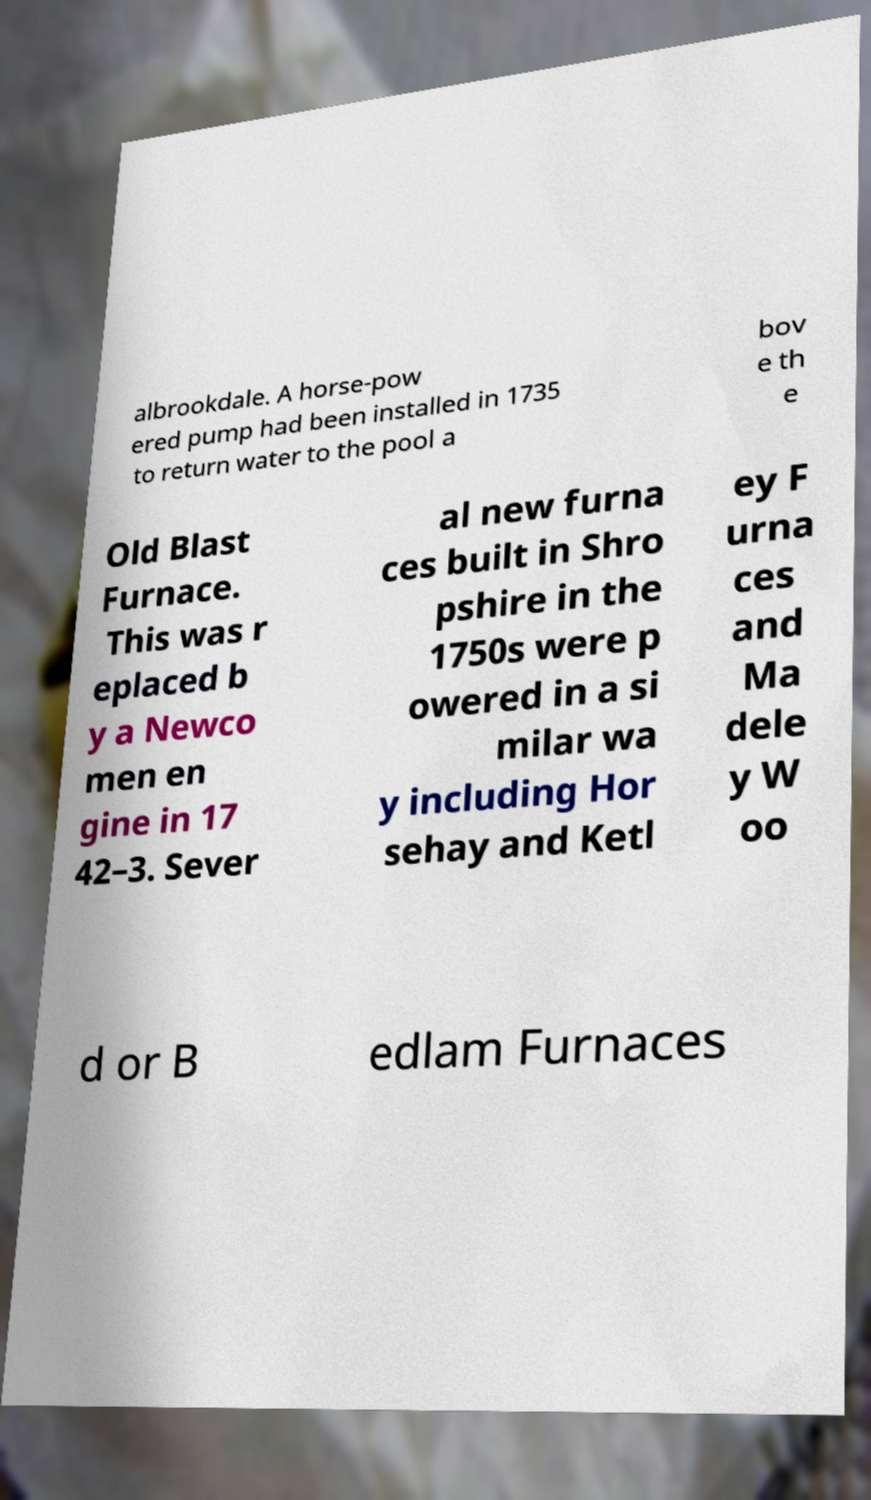What messages or text are displayed in this image? I need them in a readable, typed format. albrookdale. A horse-pow ered pump had been installed in 1735 to return water to the pool a bov e th e Old Blast Furnace. This was r eplaced b y a Newco men en gine in 17 42–3. Sever al new furna ces built in Shro pshire in the 1750s were p owered in a si milar wa y including Hor sehay and Ketl ey F urna ces and Ma dele y W oo d or B edlam Furnaces 